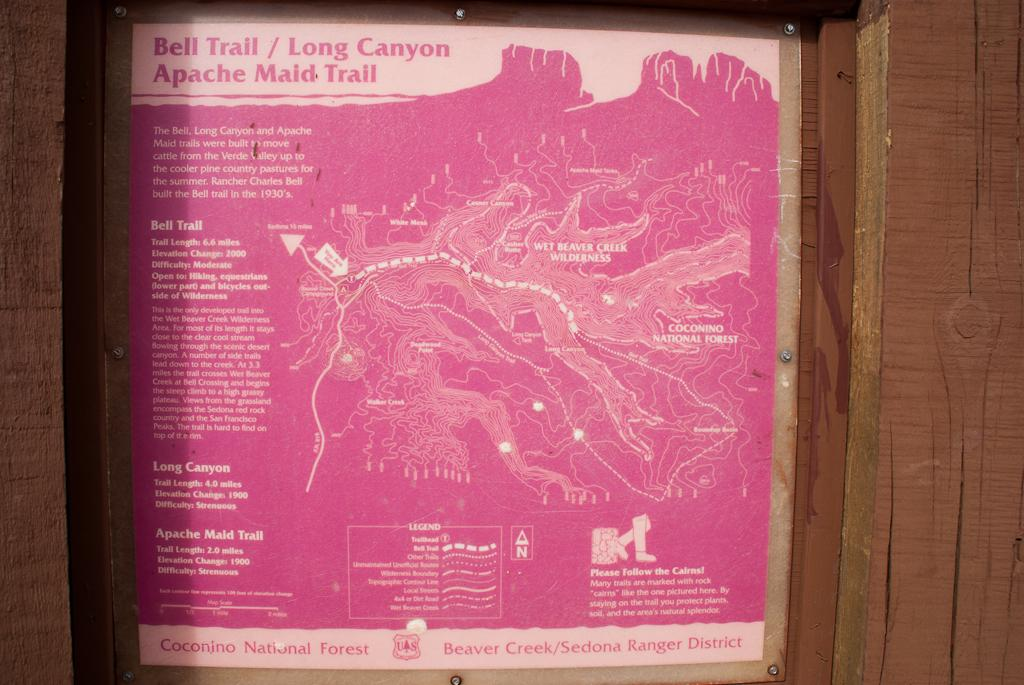<image>
Render a clear and concise summary of the photo. a pink poster stating Bell Trail/ Long Canyon Apache Maid Trail. 